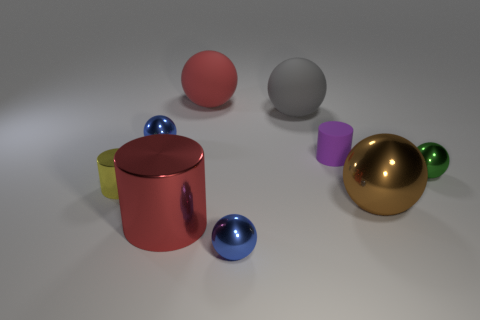There is a tiny yellow thing that is made of the same material as the brown ball; what shape is it?
Ensure brevity in your answer.  Cylinder. There is a tiny cylinder that is behind the tiny metal cylinder; is there a big red rubber thing that is on the left side of it?
Your answer should be compact. Yes. How big is the purple matte cylinder?
Your answer should be compact. Small. What number of objects are small shiny balls or small yellow metallic cylinders?
Your response must be concise. 4. Is the material of the object that is to the right of the brown sphere the same as the large red object that is in front of the tiny purple rubber cylinder?
Your response must be concise. Yes. What color is the other sphere that is the same material as the big red sphere?
Your response must be concise. Gray. How many other rubber things are the same size as the gray object?
Give a very brief answer. 1. What number of other things are there of the same color as the big shiny cylinder?
Offer a very short reply. 1. Is there anything else that is the same size as the gray ball?
Keep it short and to the point. Yes. Do the blue shiny object in front of the small yellow metallic thing and the big metallic thing behind the big red metal thing have the same shape?
Keep it short and to the point. Yes. 